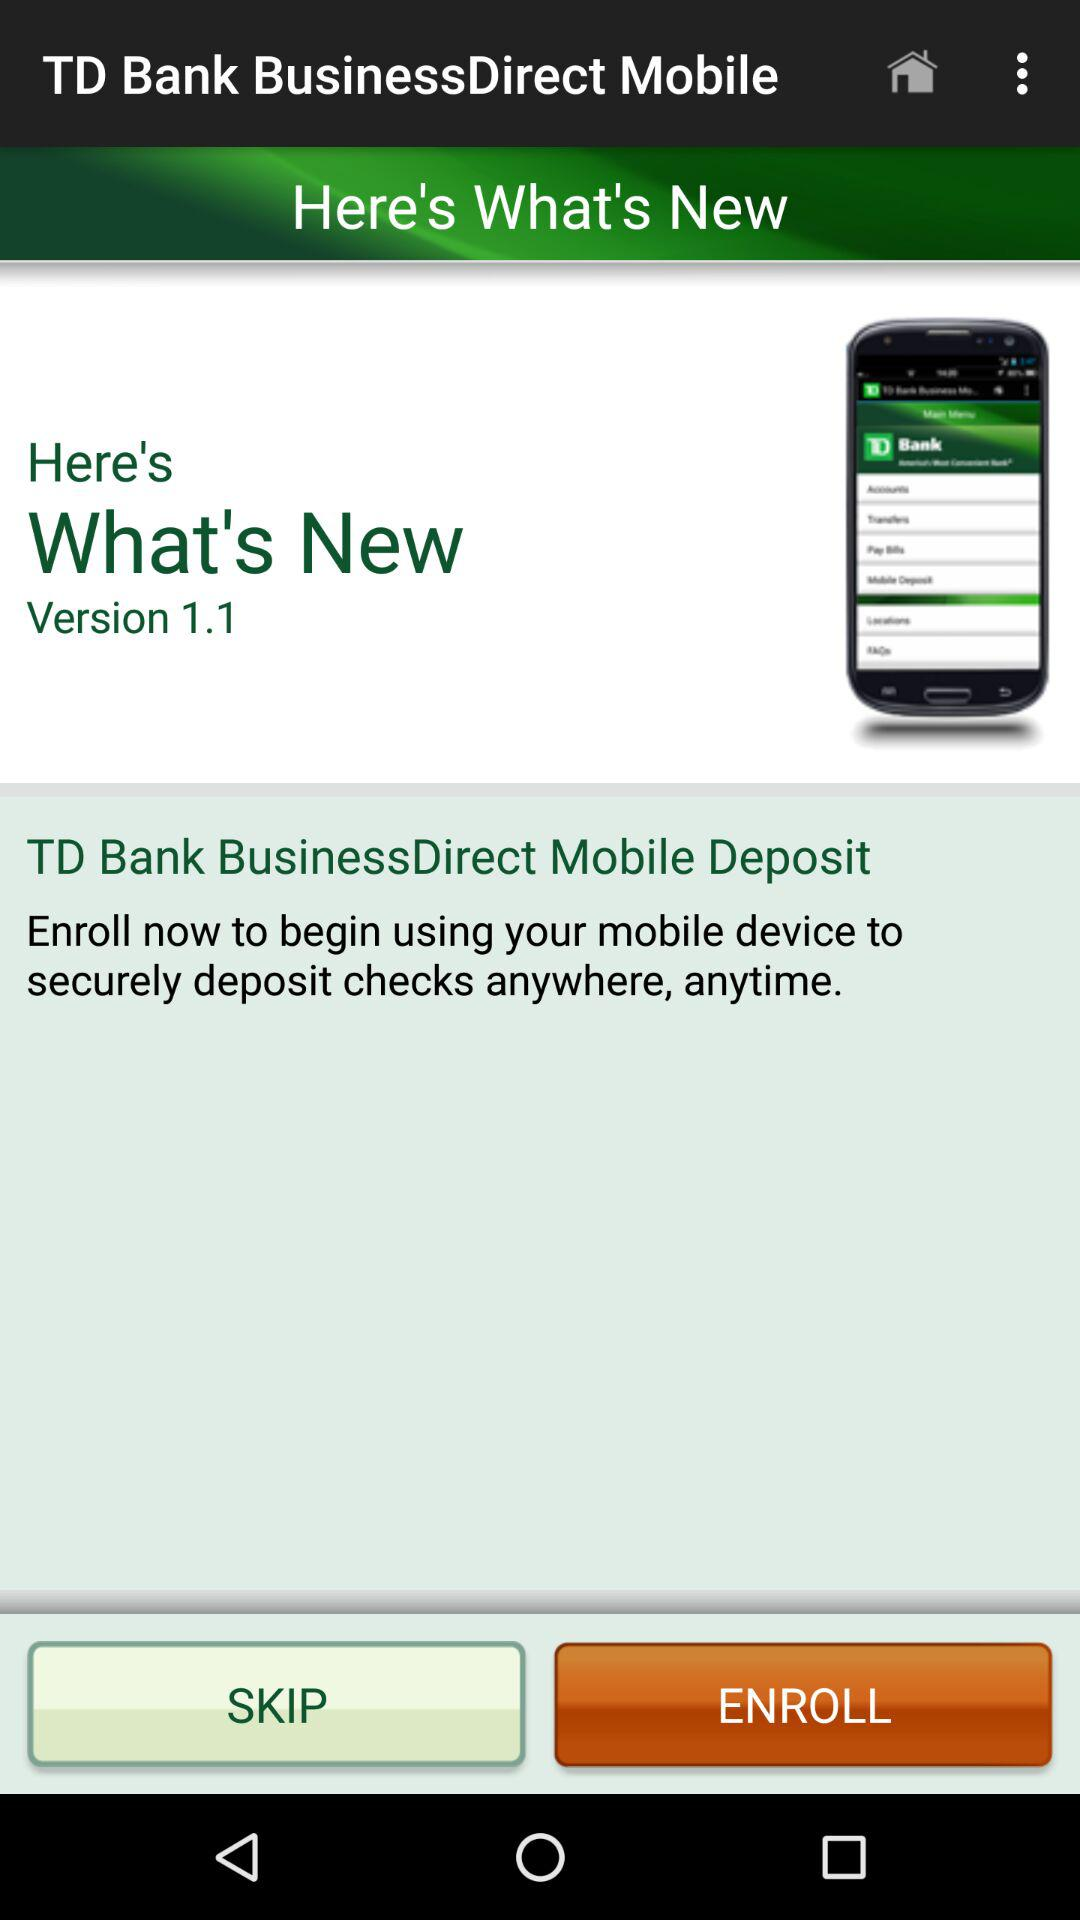What is the latest version of application being used? The latest version of the application being used is 1.1. 